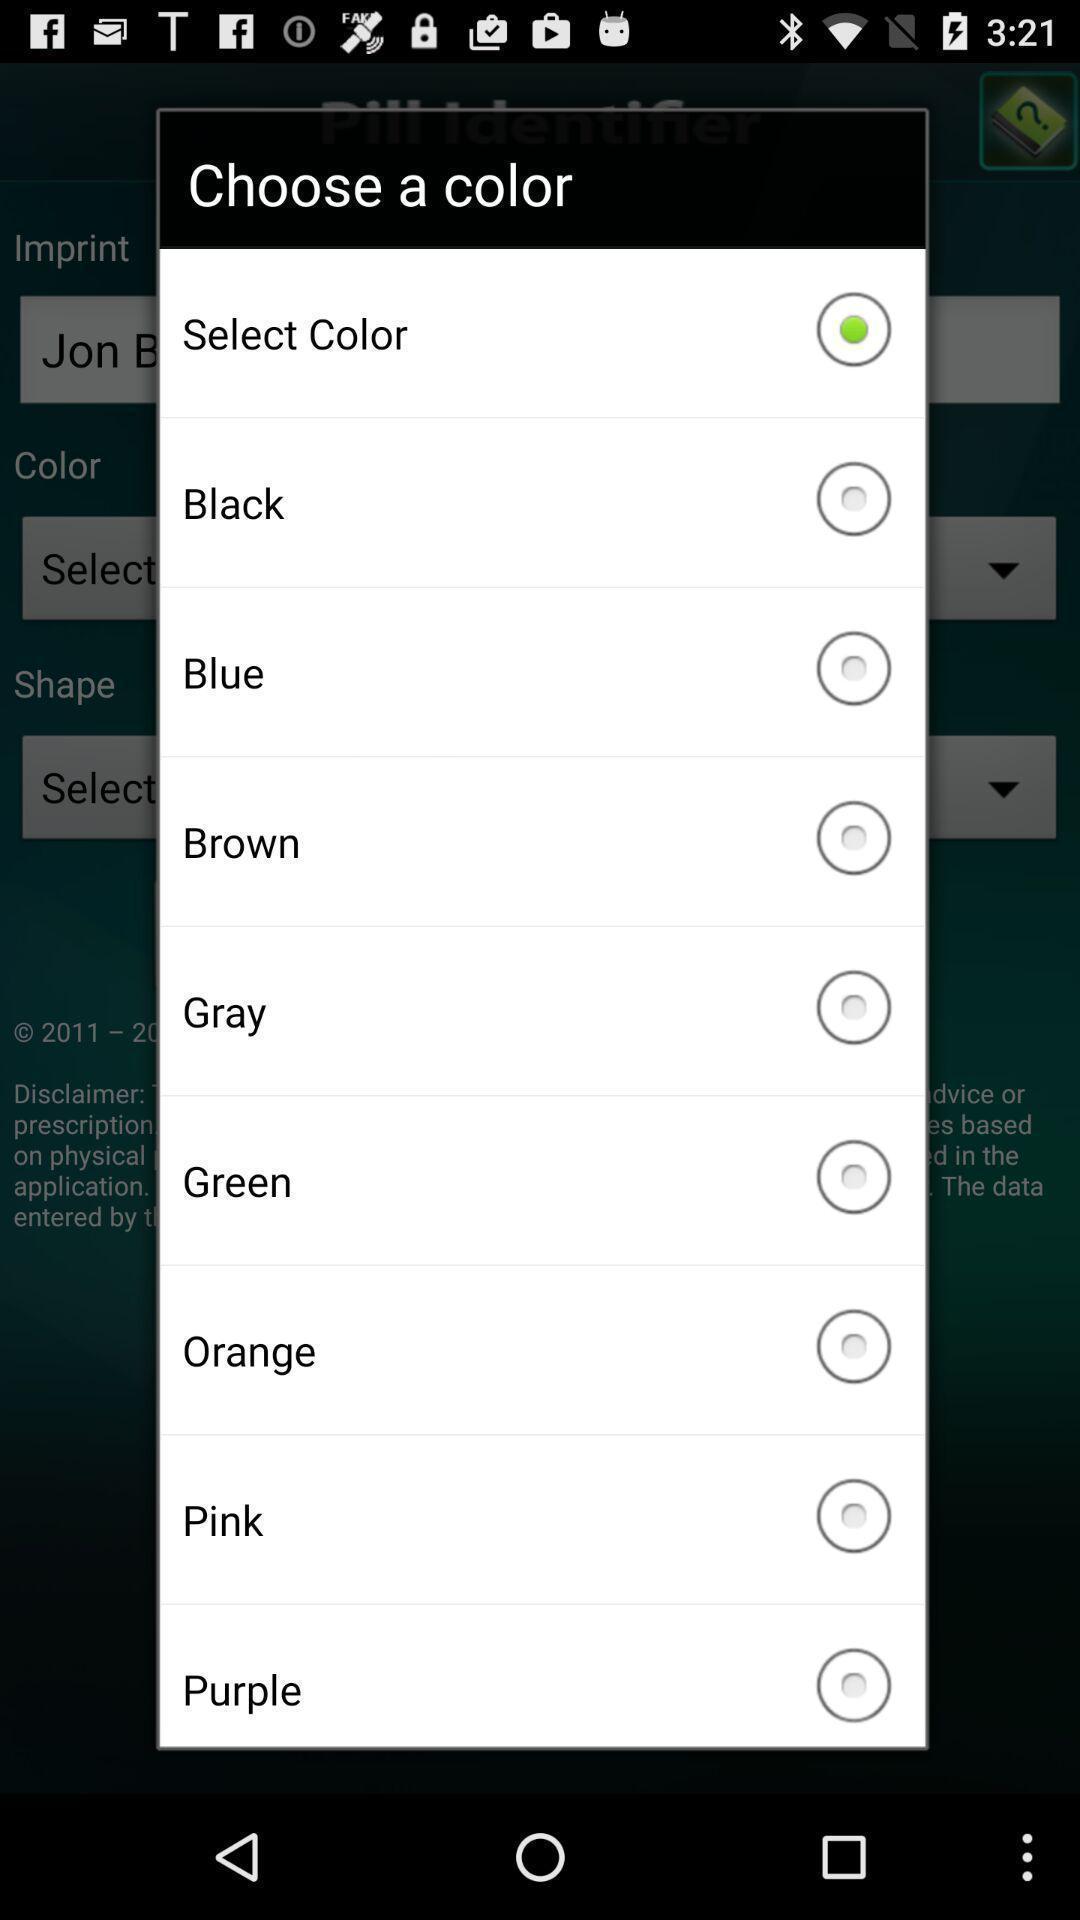Describe the key features of this screenshot. Screen shows to choose a color. 